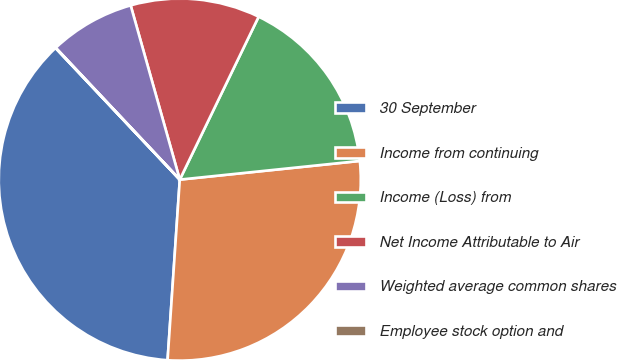Convert chart to OTSL. <chart><loc_0><loc_0><loc_500><loc_500><pie_chart><fcel>30 September<fcel>Income from continuing<fcel>Income (Loss) from<fcel>Net Income Attributable to Air<fcel>Weighted average common shares<fcel>Employee stock option and<nl><fcel>36.88%<fcel>27.72%<fcel>16.18%<fcel>11.55%<fcel>7.64%<fcel>0.03%<nl></chart> 